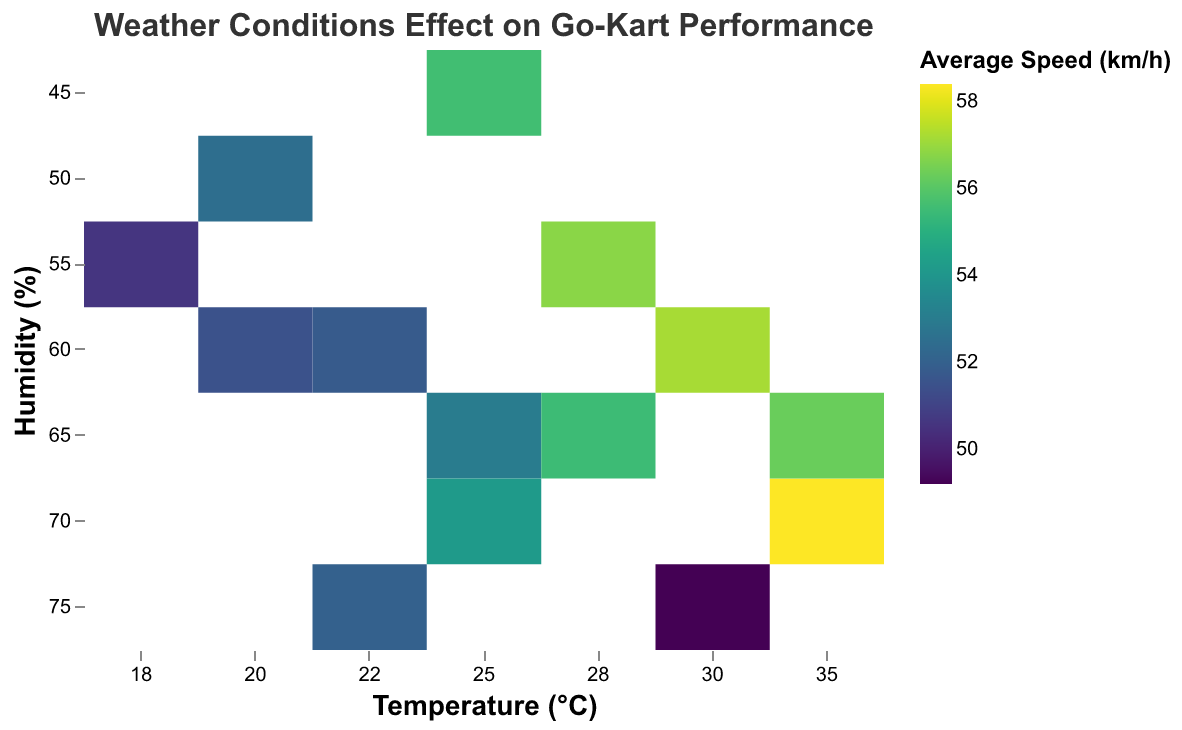What is the title of the heatmap? The title is usually prominently displayed at the top of the chart and describes the focus of the visualization.
Answer: Weather Conditions Effect on Go-Kart Performance Which variable is shown on the x-axis? The x-axis is labeled to represent a specific variable being measured or compared across different categories.
Answer: Temperature (°C) Which variable is shown on the y-axis? The y-axis label indicates the variable that is contrasted against the x-axis variable in the visualization.
Answer: Humidity (%) What color scheme is used to represent the average speed? The color legend indicates the color scheme used for representing data; in this case, it uses sequential colors typically associated with 'viridis' for average speed values.
Answer: Viridis What is the tooltip information displayed when you hover over a data point? Tooltips reveal detailed data for a specific point when hovered over, providing values for various metrics.
Answer: Temperature, Humidity, Track Condition, Average Speed, Lap Time, Grip Level What is the highest average speed recorded and under what conditions? To find the highest average speed, look at the color gradient in the heatmap and then refer to the respective tooltip for exact conditions.
Answer: 58.4 km/h, 35°C temperature, 70% humidity, dry track Which track condition generally has the lowest average speeds? Examining the color variations in the heatmap and associating them with track conditions can reveal this.
Answer: Wet How does grip level compare between dry and wet track conditions? Hover over data points for dry and wet conditions to compare grip levels directly from tooltip information.
Answer: Higher in dry conditions What is the average speed for a 25°C temperature and 45% humidity? Locate the specific cell in the heatmap where temperature is 25°C and humidity is 45% and examine the color or tooltip.
Answer: 55.6 km/h What is the trend in lap times as humidity increases on a dry track? Observe the color gradients associated with lap times for different humidity levels under dry track conditions to infer the trend.
Answer: Lap times generally decrease as humidity increases on a dry track 